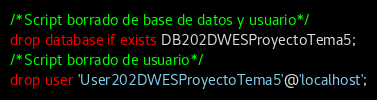Convert code to text. <code><loc_0><loc_0><loc_500><loc_500><_SQL_>/*Script borrado de base de datos y usuario*/
drop database if exists DB202DWESProyectoTema5;
/*Script borrado de usuario*/
drop user 'User202DWESProyectoTema5'@'localhost';
</code> 